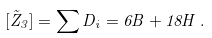<formula> <loc_0><loc_0><loc_500><loc_500>[ \tilde { Z } _ { 3 } ] = \sum D _ { i } = 6 B + 1 8 H \, .</formula> 